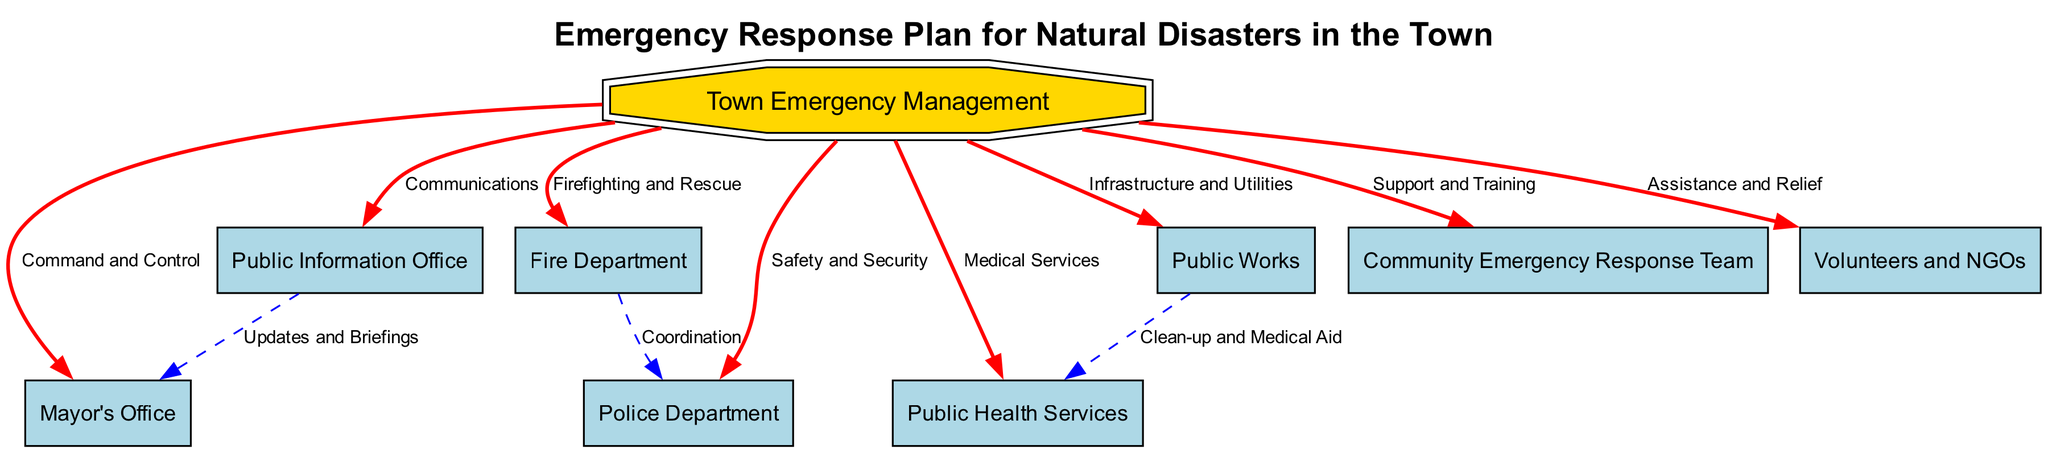What is the main authority in the emergency response plan? The main authority, identified in the diagram as the top node, is "Town Emergency Management," which oversees the entire emergency plan.
Answer: Town Emergency Management How many departments are directly connected to the Town Emergency Management? The diagram shows six departments connected directly to "Town Emergency Management" through edges, indicating their support roles in the emergency response.
Answer: 6 What role does the Public Information Office have in the emergency response plan? The "Public Information Office" primarily manages "Communications" as indicated by the edge connecting it to "Town Emergency Management," showing its function in relaying information.
Answer: Communications Which two entities are responsible for coordinating safety during a natural disaster? The "Fire Department" and "Police Department" are both directly connected to "Town Emergency Management," indicating their collaborative role in ensuring "Safety and Security" during emergencies.
Answer: Fire Department and Police Department What connection exists between Public Works and Public Health Services? The diagram shows that they are connected indirectly, with "Public Works" providing "Clean-up" services that link to "Medical Aid" from "Public Health Services," highlighting collaboration in disaster management.
Answer: Clean-up and Medical Aid Who provides assistance and relief during an emergency? The "Volunteers and NGOs" are responsible for "Assistance and Relief," as displayed by their direct connection to "Town Emergency Management" in the diagram.
Answer: Volunteers and NGOs How many total nodes are represented in the diagram? The diagram displays a total of nine nodes, each representing key roles and responsibilities within the emergency response plan, including departments and teams.
Answer: 9 Which department is responsible for medical services? The "Public Health Services" node in the diagram is directly linked to "Town Emergency Management" and indicated as responsible for "Medical Services."
Answer: Public Health Services What type of relationship is depicted between the Fire Department and Police Department? The diagram portrays a "Coordination" relationship between the Fire Department and Police Department, reflecting their joint efforts in managing emergencies.
Answer: Coordination 